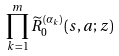<formula> <loc_0><loc_0><loc_500><loc_500>\prod _ { k = 1 } ^ { m } \widetilde { R } _ { 0 } ^ { ( \alpha _ { k } ) } ( s , a ; z )</formula> 